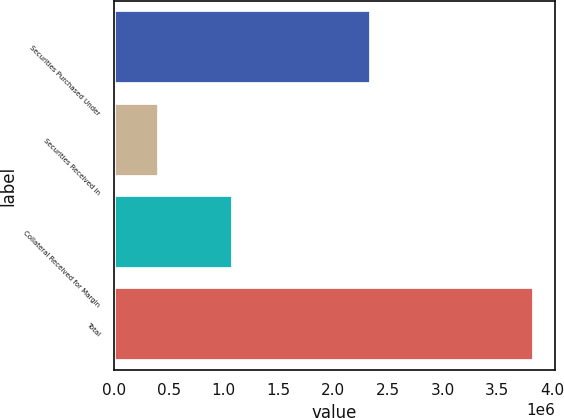<chart> <loc_0><loc_0><loc_500><loc_500><bar_chart><fcel>Securities Purchased Under<fcel>Securities Received in<fcel>Collateral Received for Margin<fcel>Total<nl><fcel>2.34707e+06<fcel>407314<fcel>1.08291e+06<fcel>3.8373e+06<nl></chart> 